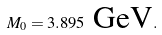Convert formula to latex. <formula><loc_0><loc_0><loc_500><loc_500>M _ { 0 } = 3 . 8 9 5 \text { GeV} .</formula> 